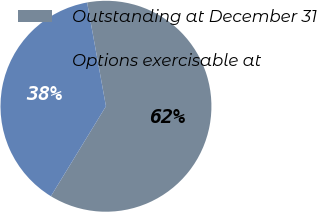Convert chart to OTSL. <chart><loc_0><loc_0><loc_500><loc_500><pie_chart><fcel>Outstanding at December 31<fcel>Options exercisable at<nl><fcel>61.6%<fcel>38.4%<nl></chart> 